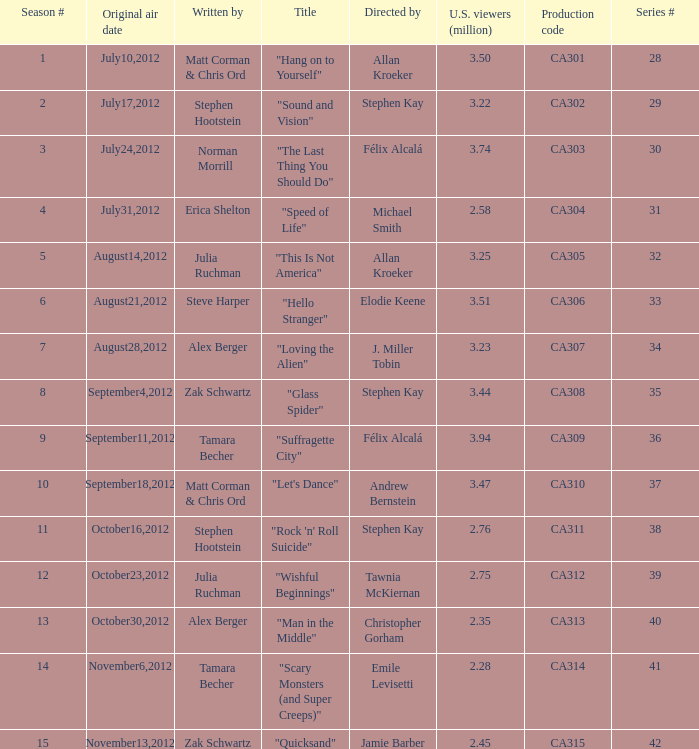Which episode had 2.75 million viewers in the U.S.? "Wishful Beginnings". 